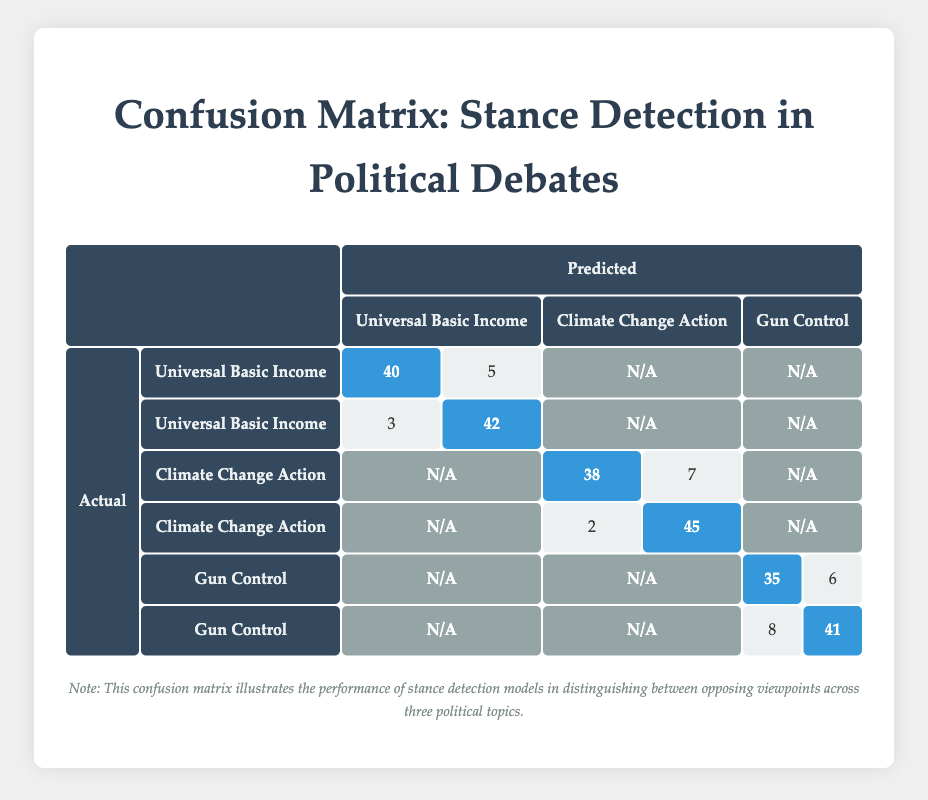What is the predicted count for "Pro-Universal Basic Income" when the actual stance is also "Pro-Universal Basic Income"? Referring to the table, we look for the entry where both the actual and predicted stances are "Pro-Universal Basic Income". The corresponding count is 40.
Answer: 40 What is the total number of predictions made regarding "Against Climate Change Action"? There are two entries for "Against Climate Change Action": one where the actual stance is "Against" and predicted stance is "Pro," with a count of 2, and another where both are "Against," with a count of 45. Therefore, the total is 2 + 45 = 47.
Answer: 47 Is the model more accurate in predicting stances for "Gun Control" compared to "Universal Basic Income"? For "Gun Control," there are 35 accurate predictions and 6 incorrect predictions, totaling 41 predictions. For "Universal Basic Income," there are 40 accurate predictions and 5 incorrect predictions, totaling 45 predictions. The model has a higher rate of accuracy for "Universal Basic Income."
Answer: No What is the ratio of correct to incorrect predictions for "Pro-Climate Change Action"? The correct predictions are 38 (Pro-Climate Change Action predicted as Pro-Climate Change Action) and incorrect are 7 (Predicted as Against Climate Change Action). The ratio is 38:7.
Answer: 38:7 What is the percentage of predictions for "Against Gun Control" that were accurately predicted? There are 41 accurate predictions out of a total of 41 + 8 = 49 predictions. The percentage is (41/49) * 100 = 83.67%.
Answer: 83.67% How many total predictions were made across all categories? Summing the counts from all entries: 40 + 5 + 3 + 42 + 38 + 7 + 2 + 45 + 35 + 6 + 8 + 41 = 328.
Answer: 328 What is the difference between the total number of correct predictions for “Pro-Universal Basic Income” and “Pro-Gun Control”? The correct predictions for Pro-Universal Basic Income are 40, and for Pro-Gun Control are 35. Therefore, the difference is 40 - 35 = 5.
Answer: 5 Did the model classify any "Against Universal Basic Income" predictions accurately? Yes, looking at the table, there are 42 correct predictions for the "Against Universal Basic Income" stance.
Answer: Yes What is the cumulative total of incorrect predictions for all stances under "Universal Basic Income"? Incorrect predictions under "Universal Basic Income" are 5 (actual Pro, predicted Against) and 3 (actual Against, predicted Pro), totaling 5 + 3 = 8.
Answer: 8 